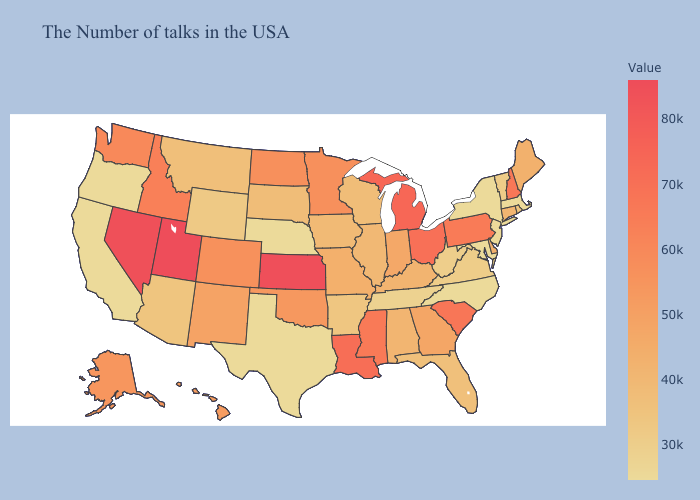Among the states that border Illinois , does Indiana have the lowest value?
Quick response, please. No. Which states have the highest value in the USA?
Give a very brief answer. Utah. Does Nebraska have the lowest value in the MidWest?
Write a very short answer. Yes. Does Ohio have the lowest value in the MidWest?
Answer briefly. No. Among the states that border Connecticut , does Massachusetts have the highest value?
Answer briefly. No. 